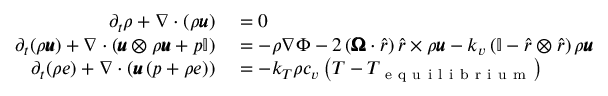Convert formula to latex. <formula><loc_0><loc_0><loc_500><loc_500>\begin{array} { r l } { \partial _ { t } \rho + \nabla \cdot \left ( \rho \pm b { u } \right ) } & = 0 } \\ { \partial _ { t } ( \rho \pm b { u } ) + \nabla \cdot \left ( \pm b { u } \otimes \rho \pm b { u } + p \mathbb { I } \right ) } & = - \rho \nabla \Phi - 2 \left ( \pm b { \Omega } \cdot \hat { r } \right ) \hat { r } \times \rho \pm b { u } - k _ { v } \left ( \mathbb { I } - \hat { r } \otimes \hat { r } \right ) \rho \pm b { u } } \\ { \partial _ { t } ( \rho e ) + \nabla \cdot \left ( \pm b { u } \left ( p + \rho e \right ) \right ) } & = - k _ { T } \rho c _ { v } \left ( T - T _ { e q u i l i b r i u m } \right ) } \end{array}</formula> 